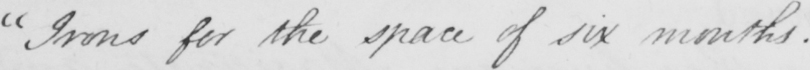What text is written in this handwritten line? " Irons for the space of six months .  _ 